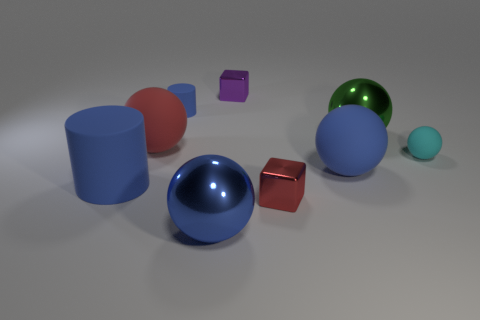There is a sphere that is left of the cylinder behind the blue cylinder that is in front of the green metal thing; what is its size?
Make the answer very short. Large. There is a big matte thing that is on the right side of the large matte ball that is to the left of the tiny purple metal thing; what color is it?
Provide a succinct answer. Blue. What number of other objects are the same material as the red sphere?
Provide a short and direct response. 4. What number of other things are there of the same color as the small matte cylinder?
Keep it short and to the point. 3. What is the blue cylinder that is in front of the blue thing behind the tiny cyan matte ball made of?
Your answer should be very brief. Rubber. Is there a cyan thing?
Provide a short and direct response. Yes. There is a blue thing that is right of the large metal thing in front of the green thing; what is its size?
Make the answer very short. Large. Is the number of tiny red metal cubes that are to the right of the red cube greater than the number of small cyan matte objects that are to the left of the red ball?
Provide a short and direct response. No. What number of blocks are small blue metal things or purple metal objects?
Your answer should be very brief. 1. Does the tiny metallic object behind the big cylinder have the same shape as the small blue matte thing?
Give a very brief answer. No. 